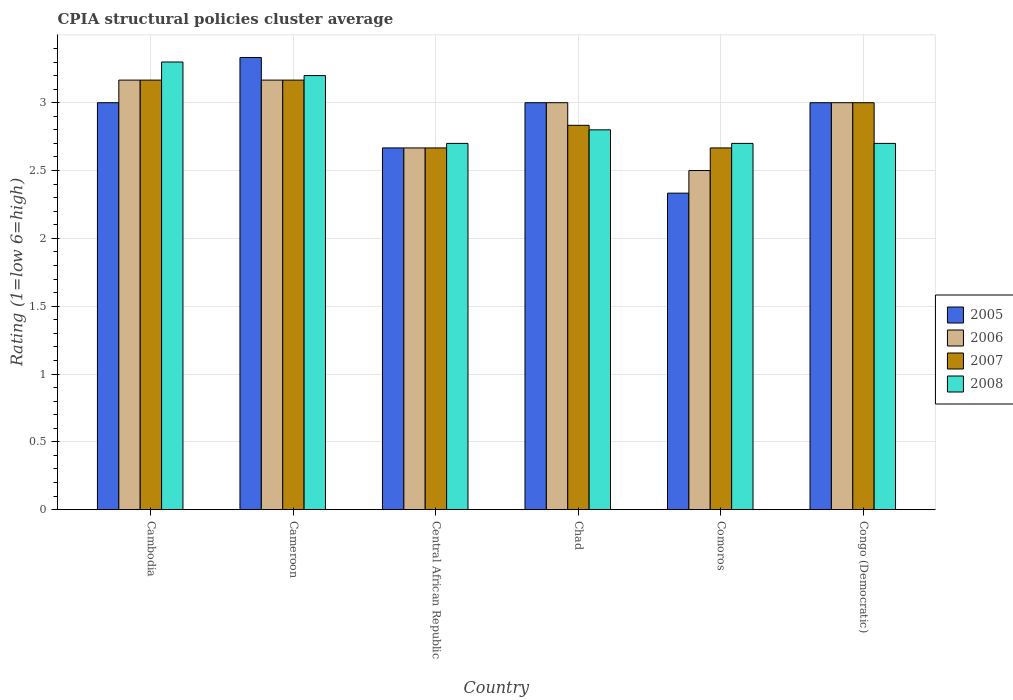How many different coloured bars are there?
Offer a terse response. 4. How many groups of bars are there?
Make the answer very short. 6. Are the number of bars on each tick of the X-axis equal?
Your response must be concise. Yes. How many bars are there on the 2nd tick from the right?
Your answer should be very brief. 4. What is the label of the 6th group of bars from the left?
Offer a terse response. Congo (Democratic). In how many cases, is the number of bars for a given country not equal to the number of legend labels?
Ensure brevity in your answer.  0. What is the CPIA rating in 2008 in Congo (Democratic)?
Your response must be concise. 2.7. Across all countries, what is the maximum CPIA rating in 2006?
Keep it short and to the point. 3.17. Across all countries, what is the minimum CPIA rating in 2007?
Offer a very short reply. 2.67. In which country was the CPIA rating in 2005 maximum?
Your answer should be compact. Cameroon. In which country was the CPIA rating in 2005 minimum?
Offer a terse response. Comoros. What is the total CPIA rating in 2005 in the graph?
Your answer should be compact. 17.33. What is the difference between the CPIA rating in 2006 in Comoros and that in Congo (Democratic)?
Your response must be concise. -0.5. What is the difference between the CPIA rating in 2006 in Cambodia and the CPIA rating in 2008 in Comoros?
Provide a short and direct response. 0.47. What is the average CPIA rating in 2005 per country?
Provide a short and direct response. 2.89. In how many countries, is the CPIA rating in 2007 greater than 0.2?
Provide a succinct answer. 6. What is the ratio of the CPIA rating in 2007 in Chad to that in Comoros?
Provide a succinct answer. 1.06. Is the difference between the CPIA rating in 2007 in Chad and Comoros greater than the difference between the CPIA rating in 2005 in Chad and Comoros?
Offer a terse response. No. What is the difference between the highest and the second highest CPIA rating in 2006?
Your response must be concise. -0.17. What is the difference between the highest and the lowest CPIA rating in 2005?
Give a very brief answer. 1. In how many countries, is the CPIA rating in 2007 greater than the average CPIA rating in 2007 taken over all countries?
Provide a succinct answer. 3. Is the sum of the CPIA rating in 2007 in Chad and Comoros greater than the maximum CPIA rating in 2006 across all countries?
Give a very brief answer. Yes. Is it the case that in every country, the sum of the CPIA rating in 2008 and CPIA rating in 2006 is greater than the sum of CPIA rating in 2007 and CPIA rating in 2005?
Your answer should be compact. No. What does the 1st bar from the right in Congo (Democratic) represents?
Provide a succinct answer. 2008. Is it the case that in every country, the sum of the CPIA rating in 2007 and CPIA rating in 2008 is greater than the CPIA rating in 2006?
Your answer should be compact. Yes. What is the difference between two consecutive major ticks on the Y-axis?
Offer a very short reply. 0.5. Are the values on the major ticks of Y-axis written in scientific E-notation?
Offer a very short reply. No. Does the graph contain grids?
Offer a terse response. Yes. Where does the legend appear in the graph?
Offer a terse response. Center right. What is the title of the graph?
Make the answer very short. CPIA structural policies cluster average. Does "1997" appear as one of the legend labels in the graph?
Provide a succinct answer. No. What is the label or title of the X-axis?
Offer a very short reply. Country. What is the label or title of the Y-axis?
Give a very brief answer. Rating (1=low 6=high). What is the Rating (1=low 6=high) of 2006 in Cambodia?
Provide a short and direct response. 3.17. What is the Rating (1=low 6=high) in 2007 in Cambodia?
Your answer should be compact. 3.17. What is the Rating (1=low 6=high) in 2008 in Cambodia?
Provide a short and direct response. 3.3. What is the Rating (1=low 6=high) of 2005 in Cameroon?
Offer a very short reply. 3.33. What is the Rating (1=low 6=high) in 2006 in Cameroon?
Your response must be concise. 3.17. What is the Rating (1=low 6=high) in 2007 in Cameroon?
Your response must be concise. 3.17. What is the Rating (1=low 6=high) in 2008 in Cameroon?
Make the answer very short. 3.2. What is the Rating (1=low 6=high) in 2005 in Central African Republic?
Keep it short and to the point. 2.67. What is the Rating (1=low 6=high) in 2006 in Central African Republic?
Give a very brief answer. 2.67. What is the Rating (1=low 6=high) in 2007 in Central African Republic?
Your answer should be compact. 2.67. What is the Rating (1=low 6=high) of 2006 in Chad?
Ensure brevity in your answer.  3. What is the Rating (1=low 6=high) in 2007 in Chad?
Keep it short and to the point. 2.83. What is the Rating (1=low 6=high) of 2008 in Chad?
Your response must be concise. 2.8. What is the Rating (1=low 6=high) of 2005 in Comoros?
Your response must be concise. 2.33. What is the Rating (1=low 6=high) of 2006 in Comoros?
Make the answer very short. 2.5. What is the Rating (1=low 6=high) of 2007 in Comoros?
Make the answer very short. 2.67. What is the Rating (1=low 6=high) of 2008 in Comoros?
Keep it short and to the point. 2.7. What is the Rating (1=low 6=high) of 2005 in Congo (Democratic)?
Make the answer very short. 3. What is the Rating (1=low 6=high) in 2007 in Congo (Democratic)?
Offer a terse response. 3. What is the Rating (1=low 6=high) in 2008 in Congo (Democratic)?
Give a very brief answer. 2.7. Across all countries, what is the maximum Rating (1=low 6=high) of 2005?
Offer a terse response. 3.33. Across all countries, what is the maximum Rating (1=low 6=high) in 2006?
Provide a short and direct response. 3.17. Across all countries, what is the maximum Rating (1=low 6=high) in 2007?
Provide a short and direct response. 3.17. Across all countries, what is the minimum Rating (1=low 6=high) of 2005?
Offer a very short reply. 2.33. Across all countries, what is the minimum Rating (1=low 6=high) in 2007?
Your answer should be very brief. 2.67. Across all countries, what is the minimum Rating (1=low 6=high) of 2008?
Your answer should be very brief. 2.7. What is the total Rating (1=low 6=high) in 2005 in the graph?
Offer a very short reply. 17.33. What is the total Rating (1=low 6=high) in 2006 in the graph?
Your response must be concise. 17.5. What is the total Rating (1=low 6=high) in 2007 in the graph?
Give a very brief answer. 17.5. What is the difference between the Rating (1=low 6=high) in 2005 in Cambodia and that in Cameroon?
Provide a short and direct response. -0.33. What is the difference between the Rating (1=low 6=high) of 2006 in Cambodia and that in Central African Republic?
Ensure brevity in your answer.  0.5. What is the difference between the Rating (1=low 6=high) in 2008 in Cambodia and that in Central African Republic?
Ensure brevity in your answer.  0.6. What is the difference between the Rating (1=low 6=high) of 2007 in Cambodia and that in Chad?
Keep it short and to the point. 0.33. What is the difference between the Rating (1=low 6=high) of 2008 in Cambodia and that in Chad?
Provide a short and direct response. 0.5. What is the difference between the Rating (1=low 6=high) in 2006 in Cambodia and that in Congo (Democratic)?
Your answer should be compact. 0.17. What is the difference between the Rating (1=low 6=high) in 2008 in Cambodia and that in Congo (Democratic)?
Ensure brevity in your answer.  0.6. What is the difference between the Rating (1=low 6=high) of 2007 in Cameroon and that in Chad?
Your answer should be compact. 0.33. What is the difference between the Rating (1=low 6=high) of 2006 in Cameroon and that in Comoros?
Offer a terse response. 0.67. What is the difference between the Rating (1=low 6=high) in 2005 in Cameroon and that in Congo (Democratic)?
Your answer should be compact. 0.33. What is the difference between the Rating (1=low 6=high) in 2008 in Central African Republic and that in Chad?
Your response must be concise. -0.1. What is the difference between the Rating (1=low 6=high) in 2007 in Central African Republic and that in Comoros?
Offer a terse response. 0. What is the difference between the Rating (1=low 6=high) in 2006 in Central African Republic and that in Congo (Democratic)?
Make the answer very short. -0.33. What is the difference between the Rating (1=low 6=high) of 2007 in Central African Republic and that in Congo (Democratic)?
Your response must be concise. -0.33. What is the difference between the Rating (1=low 6=high) in 2005 in Chad and that in Comoros?
Your response must be concise. 0.67. What is the difference between the Rating (1=low 6=high) in 2006 in Chad and that in Comoros?
Provide a short and direct response. 0.5. What is the difference between the Rating (1=low 6=high) in 2008 in Chad and that in Comoros?
Make the answer very short. 0.1. What is the difference between the Rating (1=low 6=high) in 2008 in Chad and that in Congo (Democratic)?
Keep it short and to the point. 0.1. What is the difference between the Rating (1=low 6=high) of 2005 in Comoros and that in Congo (Democratic)?
Offer a very short reply. -0.67. What is the difference between the Rating (1=low 6=high) of 2006 in Comoros and that in Congo (Democratic)?
Ensure brevity in your answer.  -0.5. What is the difference between the Rating (1=low 6=high) of 2005 in Cambodia and the Rating (1=low 6=high) of 2007 in Cameroon?
Provide a short and direct response. -0.17. What is the difference between the Rating (1=low 6=high) in 2006 in Cambodia and the Rating (1=low 6=high) in 2008 in Cameroon?
Your answer should be very brief. -0.03. What is the difference between the Rating (1=low 6=high) of 2007 in Cambodia and the Rating (1=low 6=high) of 2008 in Cameroon?
Provide a succinct answer. -0.03. What is the difference between the Rating (1=low 6=high) of 2005 in Cambodia and the Rating (1=low 6=high) of 2006 in Central African Republic?
Give a very brief answer. 0.33. What is the difference between the Rating (1=low 6=high) in 2006 in Cambodia and the Rating (1=low 6=high) in 2008 in Central African Republic?
Offer a terse response. 0.47. What is the difference between the Rating (1=low 6=high) of 2007 in Cambodia and the Rating (1=low 6=high) of 2008 in Central African Republic?
Make the answer very short. 0.47. What is the difference between the Rating (1=low 6=high) in 2005 in Cambodia and the Rating (1=low 6=high) in 2008 in Chad?
Your answer should be compact. 0.2. What is the difference between the Rating (1=low 6=high) in 2006 in Cambodia and the Rating (1=low 6=high) in 2008 in Chad?
Your response must be concise. 0.37. What is the difference between the Rating (1=low 6=high) in 2007 in Cambodia and the Rating (1=low 6=high) in 2008 in Chad?
Your response must be concise. 0.37. What is the difference between the Rating (1=low 6=high) in 2005 in Cambodia and the Rating (1=low 6=high) in 2007 in Comoros?
Keep it short and to the point. 0.33. What is the difference between the Rating (1=low 6=high) of 2005 in Cambodia and the Rating (1=low 6=high) of 2008 in Comoros?
Offer a very short reply. 0.3. What is the difference between the Rating (1=low 6=high) of 2006 in Cambodia and the Rating (1=low 6=high) of 2008 in Comoros?
Make the answer very short. 0.47. What is the difference between the Rating (1=low 6=high) of 2007 in Cambodia and the Rating (1=low 6=high) of 2008 in Comoros?
Your answer should be compact. 0.47. What is the difference between the Rating (1=low 6=high) of 2005 in Cambodia and the Rating (1=low 6=high) of 2007 in Congo (Democratic)?
Provide a succinct answer. 0. What is the difference between the Rating (1=low 6=high) of 2006 in Cambodia and the Rating (1=low 6=high) of 2007 in Congo (Democratic)?
Your answer should be compact. 0.17. What is the difference between the Rating (1=low 6=high) in 2006 in Cambodia and the Rating (1=low 6=high) in 2008 in Congo (Democratic)?
Provide a succinct answer. 0.47. What is the difference between the Rating (1=low 6=high) in 2007 in Cambodia and the Rating (1=low 6=high) in 2008 in Congo (Democratic)?
Your response must be concise. 0.47. What is the difference between the Rating (1=low 6=high) of 2005 in Cameroon and the Rating (1=low 6=high) of 2006 in Central African Republic?
Offer a very short reply. 0.67. What is the difference between the Rating (1=low 6=high) of 2005 in Cameroon and the Rating (1=low 6=high) of 2008 in Central African Republic?
Your response must be concise. 0.63. What is the difference between the Rating (1=low 6=high) in 2006 in Cameroon and the Rating (1=low 6=high) in 2007 in Central African Republic?
Keep it short and to the point. 0.5. What is the difference between the Rating (1=low 6=high) of 2006 in Cameroon and the Rating (1=low 6=high) of 2008 in Central African Republic?
Offer a terse response. 0.47. What is the difference between the Rating (1=low 6=high) in 2007 in Cameroon and the Rating (1=low 6=high) in 2008 in Central African Republic?
Your response must be concise. 0.47. What is the difference between the Rating (1=low 6=high) in 2005 in Cameroon and the Rating (1=low 6=high) in 2007 in Chad?
Offer a terse response. 0.5. What is the difference between the Rating (1=low 6=high) of 2005 in Cameroon and the Rating (1=low 6=high) of 2008 in Chad?
Offer a terse response. 0.53. What is the difference between the Rating (1=low 6=high) in 2006 in Cameroon and the Rating (1=low 6=high) in 2008 in Chad?
Keep it short and to the point. 0.37. What is the difference between the Rating (1=low 6=high) of 2007 in Cameroon and the Rating (1=low 6=high) of 2008 in Chad?
Make the answer very short. 0.37. What is the difference between the Rating (1=low 6=high) of 2005 in Cameroon and the Rating (1=low 6=high) of 2006 in Comoros?
Your response must be concise. 0.83. What is the difference between the Rating (1=low 6=high) in 2005 in Cameroon and the Rating (1=low 6=high) in 2008 in Comoros?
Your answer should be very brief. 0.63. What is the difference between the Rating (1=low 6=high) in 2006 in Cameroon and the Rating (1=low 6=high) in 2008 in Comoros?
Offer a very short reply. 0.47. What is the difference between the Rating (1=low 6=high) of 2007 in Cameroon and the Rating (1=low 6=high) of 2008 in Comoros?
Provide a short and direct response. 0.47. What is the difference between the Rating (1=low 6=high) of 2005 in Cameroon and the Rating (1=low 6=high) of 2006 in Congo (Democratic)?
Provide a short and direct response. 0.33. What is the difference between the Rating (1=low 6=high) in 2005 in Cameroon and the Rating (1=low 6=high) in 2008 in Congo (Democratic)?
Ensure brevity in your answer.  0.63. What is the difference between the Rating (1=low 6=high) in 2006 in Cameroon and the Rating (1=low 6=high) in 2007 in Congo (Democratic)?
Your answer should be very brief. 0.17. What is the difference between the Rating (1=low 6=high) of 2006 in Cameroon and the Rating (1=low 6=high) of 2008 in Congo (Democratic)?
Ensure brevity in your answer.  0.47. What is the difference between the Rating (1=low 6=high) of 2007 in Cameroon and the Rating (1=low 6=high) of 2008 in Congo (Democratic)?
Your answer should be very brief. 0.47. What is the difference between the Rating (1=low 6=high) of 2005 in Central African Republic and the Rating (1=low 6=high) of 2006 in Chad?
Offer a very short reply. -0.33. What is the difference between the Rating (1=low 6=high) in 2005 in Central African Republic and the Rating (1=low 6=high) in 2007 in Chad?
Give a very brief answer. -0.17. What is the difference between the Rating (1=low 6=high) in 2005 in Central African Republic and the Rating (1=low 6=high) in 2008 in Chad?
Provide a succinct answer. -0.13. What is the difference between the Rating (1=low 6=high) in 2006 in Central African Republic and the Rating (1=low 6=high) in 2008 in Chad?
Your response must be concise. -0.13. What is the difference between the Rating (1=low 6=high) of 2007 in Central African Republic and the Rating (1=low 6=high) of 2008 in Chad?
Your response must be concise. -0.13. What is the difference between the Rating (1=low 6=high) of 2005 in Central African Republic and the Rating (1=low 6=high) of 2006 in Comoros?
Your answer should be very brief. 0.17. What is the difference between the Rating (1=low 6=high) of 2005 in Central African Republic and the Rating (1=low 6=high) of 2008 in Comoros?
Provide a short and direct response. -0.03. What is the difference between the Rating (1=low 6=high) in 2006 in Central African Republic and the Rating (1=low 6=high) in 2007 in Comoros?
Provide a succinct answer. 0. What is the difference between the Rating (1=low 6=high) in 2006 in Central African Republic and the Rating (1=low 6=high) in 2008 in Comoros?
Provide a succinct answer. -0.03. What is the difference between the Rating (1=low 6=high) in 2007 in Central African Republic and the Rating (1=low 6=high) in 2008 in Comoros?
Provide a succinct answer. -0.03. What is the difference between the Rating (1=low 6=high) of 2005 in Central African Republic and the Rating (1=low 6=high) of 2006 in Congo (Democratic)?
Ensure brevity in your answer.  -0.33. What is the difference between the Rating (1=low 6=high) in 2005 in Central African Republic and the Rating (1=low 6=high) in 2007 in Congo (Democratic)?
Offer a terse response. -0.33. What is the difference between the Rating (1=low 6=high) of 2005 in Central African Republic and the Rating (1=low 6=high) of 2008 in Congo (Democratic)?
Make the answer very short. -0.03. What is the difference between the Rating (1=low 6=high) in 2006 in Central African Republic and the Rating (1=low 6=high) in 2007 in Congo (Democratic)?
Provide a short and direct response. -0.33. What is the difference between the Rating (1=low 6=high) in 2006 in Central African Republic and the Rating (1=low 6=high) in 2008 in Congo (Democratic)?
Your response must be concise. -0.03. What is the difference between the Rating (1=low 6=high) of 2007 in Central African Republic and the Rating (1=low 6=high) of 2008 in Congo (Democratic)?
Your answer should be compact. -0.03. What is the difference between the Rating (1=low 6=high) in 2005 in Chad and the Rating (1=low 6=high) in 2007 in Comoros?
Your answer should be compact. 0.33. What is the difference between the Rating (1=low 6=high) in 2005 in Chad and the Rating (1=low 6=high) in 2008 in Comoros?
Your answer should be very brief. 0.3. What is the difference between the Rating (1=low 6=high) in 2006 in Chad and the Rating (1=low 6=high) in 2007 in Comoros?
Provide a succinct answer. 0.33. What is the difference between the Rating (1=low 6=high) of 2006 in Chad and the Rating (1=low 6=high) of 2008 in Comoros?
Your response must be concise. 0.3. What is the difference between the Rating (1=low 6=high) in 2007 in Chad and the Rating (1=low 6=high) in 2008 in Comoros?
Keep it short and to the point. 0.13. What is the difference between the Rating (1=low 6=high) in 2005 in Chad and the Rating (1=low 6=high) in 2006 in Congo (Democratic)?
Offer a very short reply. 0. What is the difference between the Rating (1=low 6=high) of 2005 in Chad and the Rating (1=low 6=high) of 2008 in Congo (Democratic)?
Make the answer very short. 0.3. What is the difference between the Rating (1=low 6=high) of 2007 in Chad and the Rating (1=low 6=high) of 2008 in Congo (Democratic)?
Your answer should be very brief. 0.13. What is the difference between the Rating (1=low 6=high) of 2005 in Comoros and the Rating (1=low 6=high) of 2007 in Congo (Democratic)?
Provide a succinct answer. -0.67. What is the difference between the Rating (1=low 6=high) in 2005 in Comoros and the Rating (1=low 6=high) in 2008 in Congo (Democratic)?
Provide a succinct answer. -0.37. What is the difference between the Rating (1=low 6=high) of 2006 in Comoros and the Rating (1=low 6=high) of 2007 in Congo (Democratic)?
Keep it short and to the point. -0.5. What is the difference between the Rating (1=low 6=high) of 2007 in Comoros and the Rating (1=low 6=high) of 2008 in Congo (Democratic)?
Ensure brevity in your answer.  -0.03. What is the average Rating (1=low 6=high) in 2005 per country?
Offer a very short reply. 2.89. What is the average Rating (1=low 6=high) of 2006 per country?
Offer a terse response. 2.92. What is the average Rating (1=low 6=high) of 2007 per country?
Give a very brief answer. 2.92. What is the average Rating (1=low 6=high) of 2008 per country?
Make the answer very short. 2.9. What is the difference between the Rating (1=low 6=high) of 2005 and Rating (1=low 6=high) of 2006 in Cambodia?
Your response must be concise. -0.17. What is the difference between the Rating (1=low 6=high) in 2005 and Rating (1=low 6=high) in 2008 in Cambodia?
Make the answer very short. -0.3. What is the difference between the Rating (1=low 6=high) of 2006 and Rating (1=low 6=high) of 2007 in Cambodia?
Your answer should be compact. 0. What is the difference between the Rating (1=low 6=high) of 2006 and Rating (1=low 6=high) of 2008 in Cambodia?
Offer a terse response. -0.13. What is the difference between the Rating (1=low 6=high) in 2007 and Rating (1=low 6=high) in 2008 in Cambodia?
Give a very brief answer. -0.13. What is the difference between the Rating (1=low 6=high) in 2005 and Rating (1=low 6=high) in 2008 in Cameroon?
Provide a succinct answer. 0.13. What is the difference between the Rating (1=low 6=high) of 2006 and Rating (1=low 6=high) of 2008 in Cameroon?
Offer a very short reply. -0.03. What is the difference between the Rating (1=low 6=high) of 2007 and Rating (1=low 6=high) of 2008 in Cameroon?
Your answer should be compact. -0.03. What is the difference between the Rating (1=low 6=high) of 2005 and Rating (1=low 6=high) of 2006 in Central African Republic?
Make the answer very short. 0. What is the difference between the Rating (1=low 6=high) of 2005 and Rating (1=low 6=high) of 2007 in Central African Republic?
Your response must be concise. 0. What is the difference between the Rating (1=low 6=high) in 2005 and Rating (1=low 6=high) in 2008 in Central African Republic?
Your answer should be very brief. -0.03. What is the difference between the Rating (1=low 6=high) in 2006 and Rating (1=low 6=high) in 2007 in Central African Republic?
Your answer should be compact. 0. What is the difference between the Rating (1=low 6=high) of 2006 and Rating (1=low 6=high) of 2008 in Central African Republic?
Ensure brevity in your answer.  -0.03. What is the difference between the Rating (1=low 6=high) of 2007 and Rating (1=low 6=high) of 2008 in Central African Republic?
Your answer should be very brief. -0.03. What is the difference between the Rating (1=low 6=high) in 2005 and Rating (1=low 6=high) in 2006 in Chad?
Give a very brief answer. 0. What is the difference between the Rating (1=low 6=high) of 2005 and Rating (1=low 6=high) of 2007 in Chad?
Your answer should be compact. 0.17. What is the difference between the Rating (1=low 6=high) of 2007 and Rating (1=low 6=high) of 2008 in Chad?
Make the answer very short. 0.03. What is the difference between the Rating (1=low 6=high) in 2005 and Rating (1=low 6=high) in 2006 in Comoros?
Keep it short and to the point. -0.17. What is the difference between the Rating (1=low 6=high) of 2005 and Rating (1=low 6=high) of 2007 in Comoros?
Your answer should be compact. -0.33. What is the difference between the Rating (1=low 6=high) of 2005 and Rating (1=low 6=high) of 2008 in Comoros?
Keep it short and to the point. -0.37. What is the difference between the Rating (1=low 6=high) in 2007 and Rating (1=low 6=high) in 2008 in Comoros?
Keep it short and to the point. -0.03. What is the difference between the Rating (1=low 6=high) of 2005 and Rating (1=low 6=high) of 2006 in Congo (Democratic)?
Your answer should be very brief. 0. What is the difference between the Rating (1=low 6=high) in 2005 and Rating (1=low 6=high) in 2008 in Congo (Democratic)?
Offer a terse response. 0.3. What is the difference between the Rating (1=low 6=high) in 2006 and Rating (1=low 6=high) in 2007 in Congo (Democratic)?
Make the answer very short. 0. What is the difference between the Rating (1=low 6=high) in 2006 and Rating (1=low 6=high) in 2008 in Congo (Democratic)?
Your answer should be very brief. 0.3. What is the ratio of the Rating (1=low 6=high) in 2005 in Cambodia to that in Cameroon?
Provide a short and direct response. 0.9. What is the ratio of the Rating (1=low 6=high) in 2006 in Cambodia to that in Cameroon?
Keep it short and to the point. 1. What is the ratio of the Rating (1=low 6=high) of 2008 in Cambodia to that in Cameroon?
Offer a very short reply. 1.03. What is the ratio of the Rating (1=low 6=high) of 2006 in Cambodia to that in Central African Republic?
Your response must be concise. 1.19. What is the ratio of the Rating (1=low 6=high) of 2007 in Cambodia to that in Central African Republic?
Your answer should be very brief. 1.19. What is the ratio of the Rating (1=low 6=high) of 2008 in Cambodia to that in Central African Republic?
Your response must be concise. 1.22. What is the ratio of the Rating (1=low 6=high) in 2005 in Cambodia to that in Chad?
Make the answer very short. 1. What is the ratio of the Rating (1=low 6=high) in 2006 in Cambodia to that in Chad?
Your response must be concise. 1.06. What is the ratio of the Rating (1=low 6=high) of 2007 in Cambodia to that in Chad?
Your response must be concise. 1.12. What is the ratio of the Rating (1=low 6=high) in 2008 in Cambodia to that in Chad?
Your response must be concise. 1.18. What is the ratio of the Rating (1=low 6=high) in 2005 in Cambodia to that in Comoros?
Offer a terse response. 1.29. What is the ratio of the Rating (1=low 6=high) in 2006 in Cambodia to that in Comoros?
Your response must be concise. 1.27. What is the ratio of the Rating (1=low 6=high) in 2007 in Cambodia to that in Comoros?
Provide a succinct answer. 1.19. What is the ratio of the Rating (1=low 6=high) of 2008 in Cambodia to that in Comoros?
Your answer should be compact. 1.22. What is the ratio of the Rating (1=low 6=high) of 2006 in Cambodia to that in Congo (Democratic)?
Provide a short and direct response. 1.06. What is the ratio of the Rating (1=low 6=high) of 2007 in Cambodia to that in Congo (Democratic)?
Offer a terse response. 1.06. What is the ratio of the Rating (1=low 6=high) of 2008 in Cambodia to that in Congo (Democratic)?
Keep it short and to the point. 1.22. What is the ratio of the Rating (1=low 6=high) in 2006 in Cameroon to that in Central African Republic?
Your response must be concise. 1.19. What is the ratio of the Rating (1=low 6=high) of 2007 in Cameroon to that in Central African Republic?
Keep it short and to the point. 1.19. What is the ratio of the Rating (1=low 6=high) of 2008 in Cameroon to that in Central African Republic?
Give a very brief answer. 1.19. What is the ratio of the Rating (1=low 6=high) of 2005 in Cameroon to that in Chad?
Ensure brevity in your answer.  1.11. What is the ratio of the Rating (1=low 6=high) in 2006 in Cameroon to that in Chad?
Ensure brevity in your answer.  1.06. What is the ratio of the Rating (1=low 6=high) of 2007 in Cameroon to that in Chad?
Give a very brief answer. 1.12. What is the ratio of the Rating (1=low 6=high) of 2005 in Cameroon to that in Comoros?
Your answer should be compact. 1.43. What is the ratio of the Rating (1=low 6=high) of 2006 in Cameroon to that in Comoros?
Provide a succinct answer. 1.27. What is the ratio of the Rating (1=low 6=high) of 2007 in Cameroon to that in Comoros?
Offer a terse response. 1.19. What is the ratio of the Rating (1=low 6=high) in 2008 in Cameroon to that in Comoros?
Ensure brevity in your answer.  1.19. What is the ratio of the Rating (1=low 6=high) in 2005 in Cameroon to that in Congo (Democratic)?
Give a very brief answer. 1.11. What is the ratio of the Rating (1=low 6=high) in 2006 in Cameroon to that in Congo (Democratic)?
Make the answer very short. 1.06. What is the ratio of the Rating (1=low 6=high) of 2007 in Cameroon to that in Congo (Democratic)?
Offer a very short reply. 1.06. What is the ratio of the Rating (1=low 6=high) in 2008 in Cameroon to that in Congo (Democratic)?
Offer a very short reply. 1.19. What is the ratio of the Rating (1=low 6=high) in 2005 in Central African Republic to that in Chad?
Make the answer very short. 0.89. What is the ratio of the Rating (1=low 6=high) of 2007 in Central African Republic to that in Chad?
Make the answer very short. 0.94. What is the ratio of the Rating (1=low 6=high) in 2008 in Central African Republic to that in Chad?
Offer a very short reply. 0.96. What is the ratio of the Rating (1=low 6=high) of 2006 in Central African Republic to that in Comoros?
Provide a short and direct response. 1.07. What is the ratio of the Rating (1=low 6=high) in 2008 in Central African Republic to that in Comoros?
Your response must be concise. 1. What is the ratio of the Rating (1=low 6=high) in 2007 in Central African Republic to that in Congo (Democratic)?
Your response must be concise. 0.89. What is the ratio of the Rating (1=low 6=high) of 2006 in Chad to that in Comoros?
Give a very brief answer. 1.2. What is the ratio of the Rating (1=low 6=high) of 2007 in Chad to that in Comoros?
Provide a succinct answer. 1.06. What is the ratio of the Rating (1=low 6=high) of 2005 in Chad to that in Congo (Democratic)?
Your response must be concise. 1. What is the ratio of the Rating (1=low 6=high) in 2006 in Chad to that in Congo (Democratic)?
Your response must be concise. 1. What is the ratio of the Rating (1=low 6=high) of 2008 in Chad to that in Congo (Democratic)?
Provide a succinct answer. 1.04. What is the difference between the highest and the second highest Rating (1=low 6=high) of 2005?
Make the answer very short. 0.33. What is the difference between the highest and the second highest Rating (1=low 6=high) in 2006?
Offer a terse response. 0. What is the difference between the highest and the second highest Rating (1=low 6=high) of 2007?
Make the answer very short. 0. What is the difference between the highest and the second highest Rating (1=low 6=high) in 2008?
Offer a very short reply. 0.1. What is the difference between the highest and the lowest Rating (1=low 6=high) in 2006?
Your answer should be compact. 0.67. 